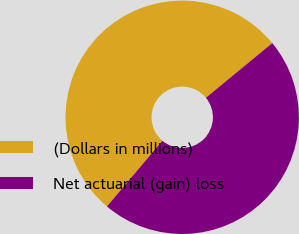Convert chart to OTSL. <chart><loc_0><loc_0><loc_500><loc_500><pie_chart><fcel>(Dollars in millions)<fcel>Net actuarial (gain) loss<nl><fcel>52.87%<fcel>47.13%<nl></chart> 